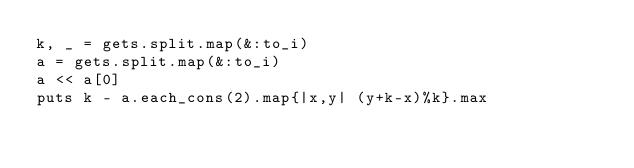<code> <loc_0><loc_0><loc_500><loc_500><_Ruby_>k, _ = gets.split.map(&:to_i)
a = gets.split.map(&:to_i)
a << a[0]
puts k - a.each_cons(2).map{|x,y| (y+k-x)%k}.max</code> 